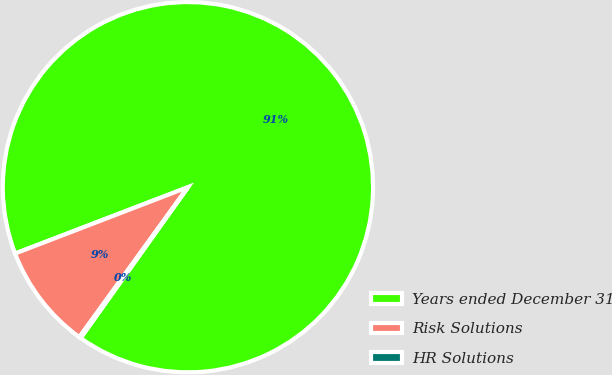Convert chart. <chart><loc_0><loc_0><loc_500><loc_500><pie_chart><fcel>Years ended December 31<fcel>Risk Solutions<fcel>HR Solutions<nl><fcel>90.68%<fcel>9.19%<fcel>0.14%<nl></chart> 